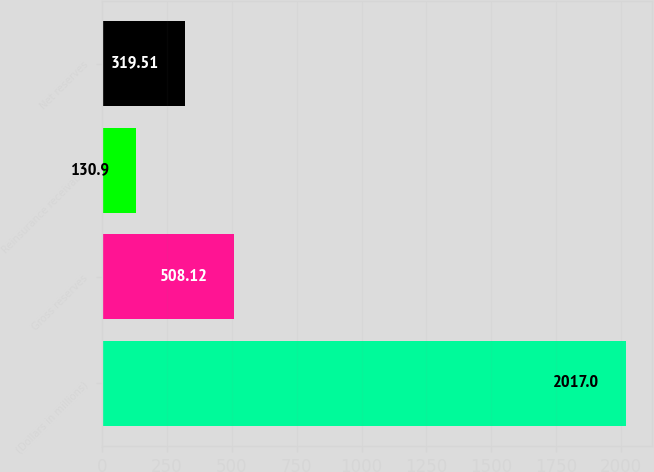Convert chart. <chart><loc_0><loc_0><loc_500><loc_500><bar_chart><fcel>(Dollars in millions)<fcel>Gross reserves<fcel>Reinsurance receivable<fcel>Net reserves<nl><fcel>2017<fcel>508.12<fcel>130.9<fcel>319.51<nl></chart> 